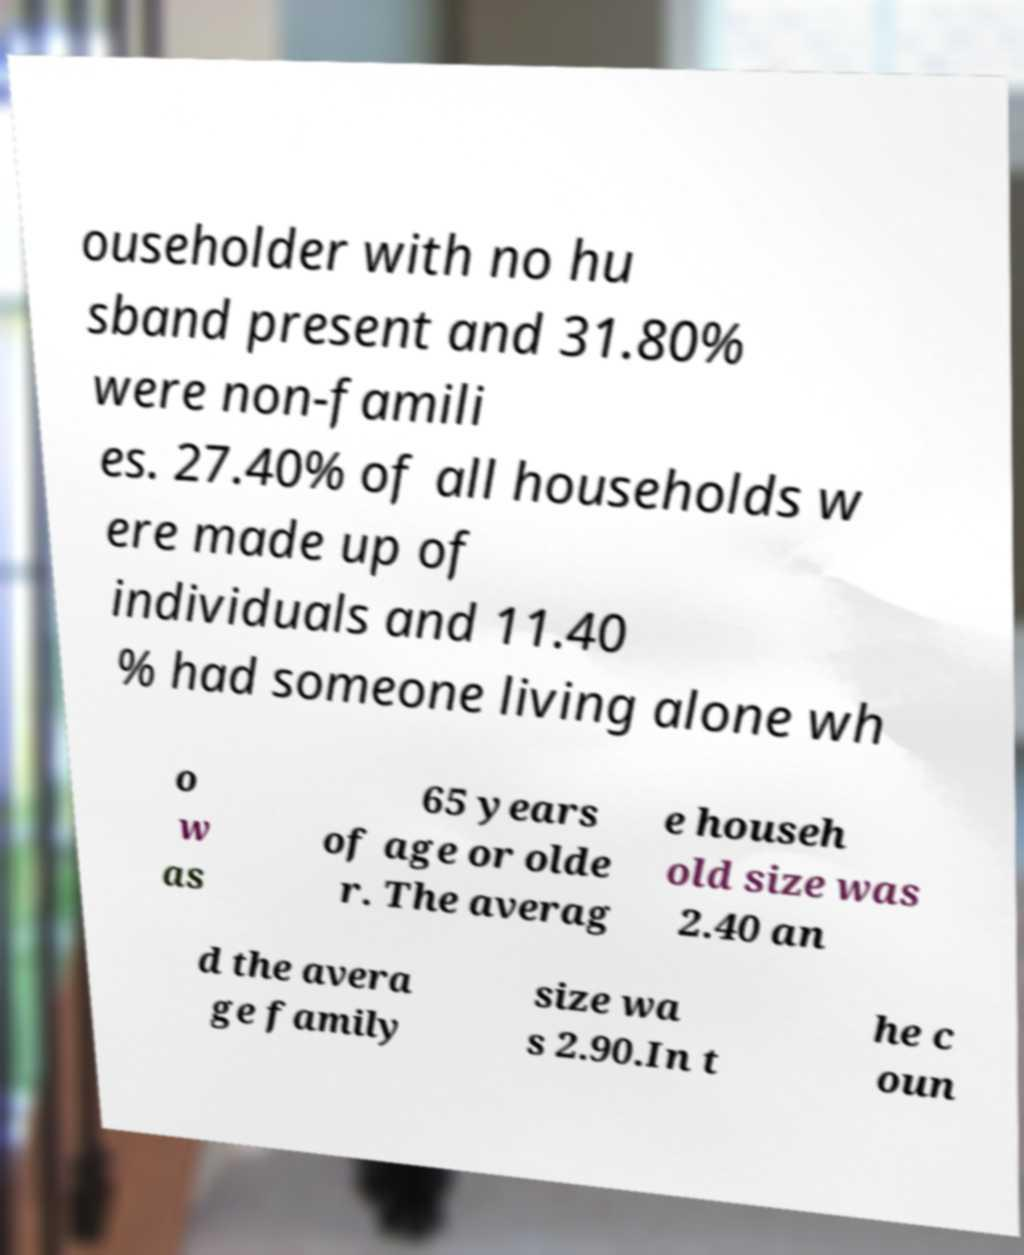There's text embedded in this image that I need extracted. Can you transcribe it verbatim? ouseholder with no hu sband present and 31.80% were non-famili es. 27.40% of all households w ere made up of individuals and 11.40 % had someone living alone wh o w as 65 years of age or olde r. The averag e househ old size was 2.40 an d the avera ge family size wa s 2.90.In t he c oun 